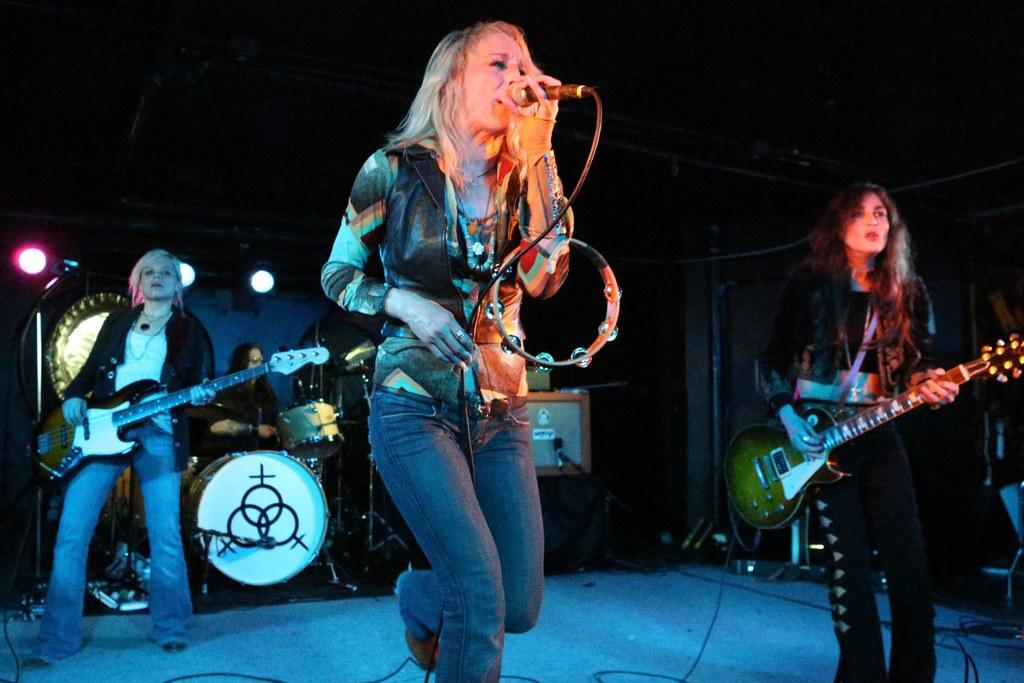What is happening on the stage in the image? There are people on the stage performing. What are the people on the stage doing? They are playing musical instruments. Is there a vocalist among the performers? Yes, there is a woman singing on a microphone. What type of glove is being used by the performers on the stage? There is no glove visible in the image; the performers are playing musical instruments and singing. 